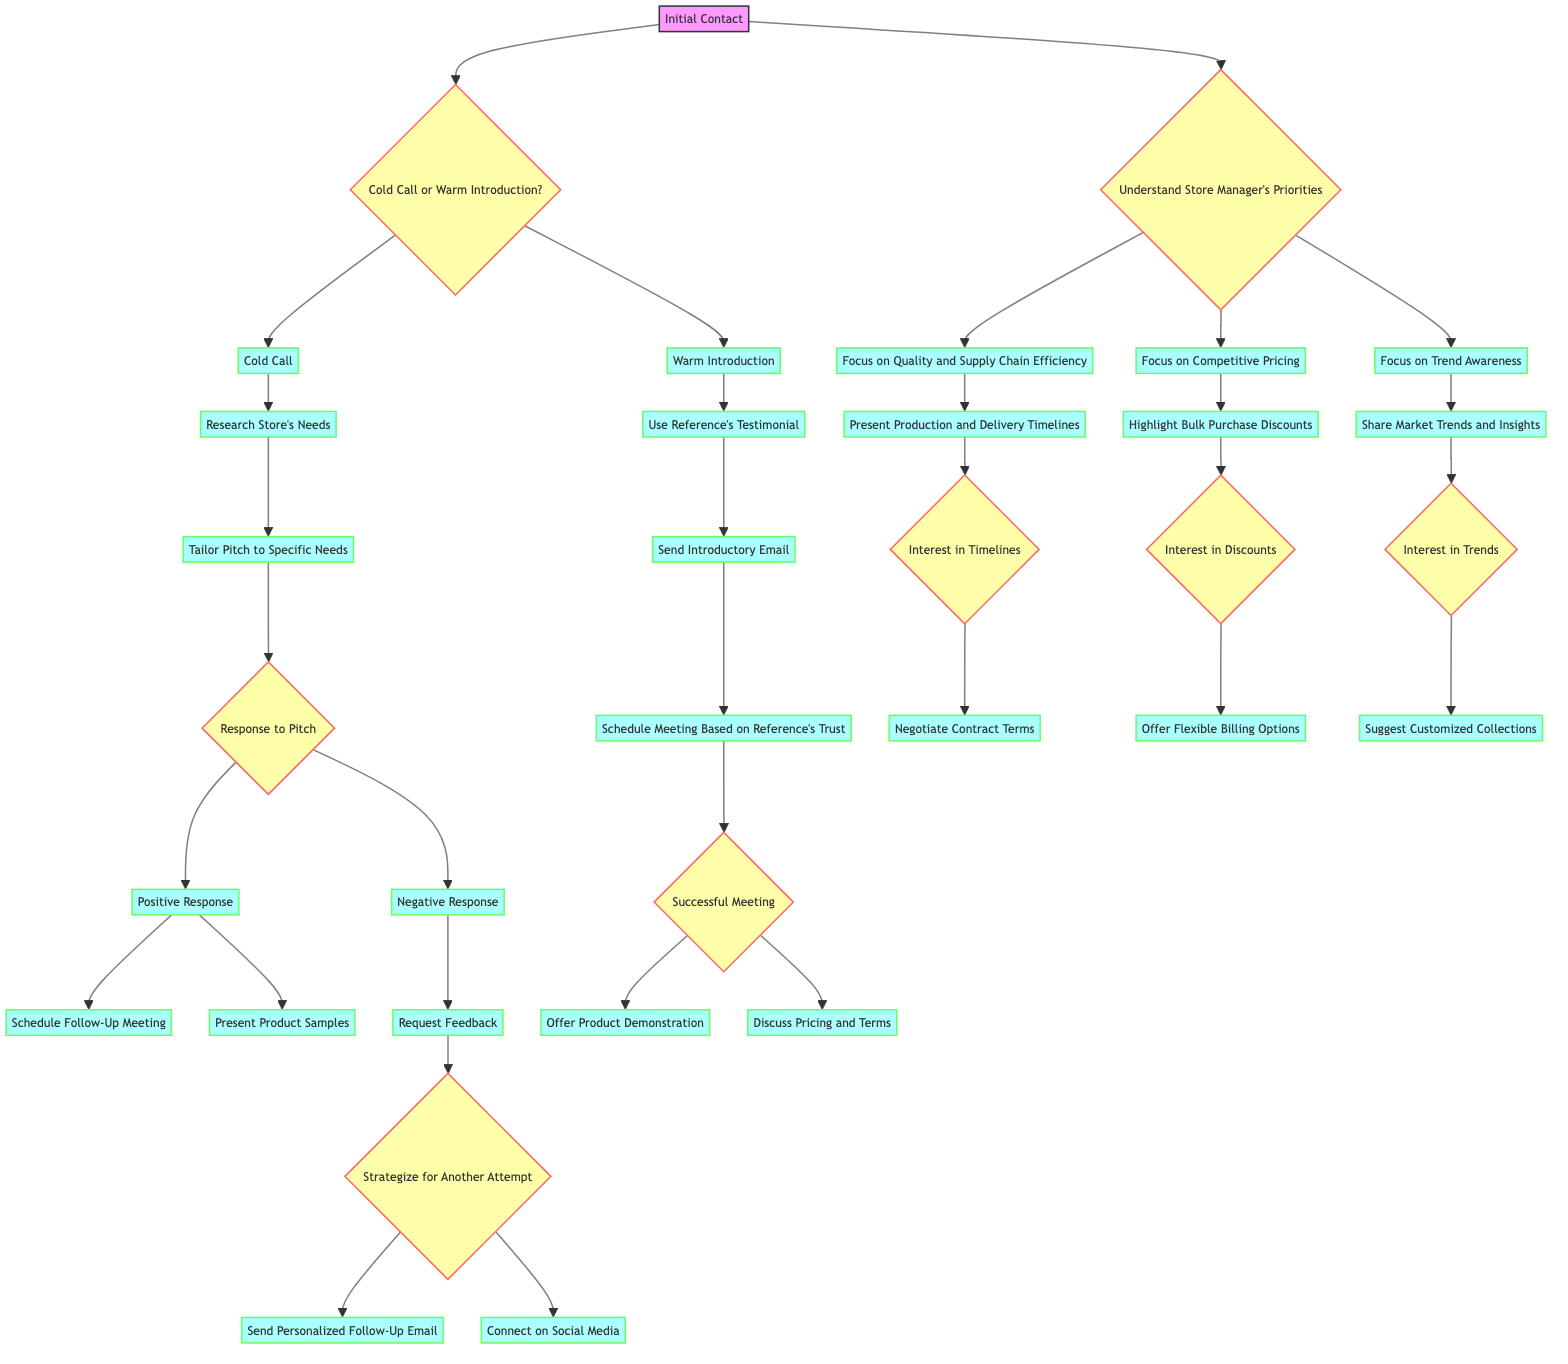What is the starting action in this decision tree? The starting action is indicated by the root node at the top of the diagram, which is "Initial Contact."
Answer: Initial Contact How many main branches are there from the "Cold Call or Warm Introduction" decision? The decision labeled "Cold Call or Warm Introduction" leads to two distinct branches: "Cold Call" and "Warm Introduction," totaling two main branches.
Answer: 2 What action follows a positive response to the tailored pitch? After a positive response is given in the response to the pitch, two actions are presented, one of which is to "Schedule Follow-Up Meeting."
Answer: Schedule Follow-Up Meeting What decision occurs after the "Research Store's Needs" action? The "Research Store's Needs" leads to the action of tailoring the pitch to specific needs, followed by a decision point called "Response to Pitch."
Answer: Response to Pitch If a store manager is interested in trends, which action is suggested next? According to the flow, following the interest in trends, the next suggested action is to "Suggest Customized Collections."
Answer: Suggest Customized Collections What happens if the meeting based on the reference's trust is unsuccessful? The diagram does not explicitly state subsequent actions for an unsuccessful meeting, suggesting that the flow ends there at the successful meeting decision.
Answer: No specific action If a store manager expresses interest in delivery timelines, what is the next action suggested? If there is an interest in timelines, the next action suggested is to "Negotiate Contract Terms," indicating the flow of decisions.
Answer: Negotiate Contract Terms Which action is taken if the response to the pitch is negative? If the response to the pitch is negative, the action taken next is to "Request Feedback," continuing the decision-making process.
Answer: Request Feedback Which focus area has an action related to highlighting bulk purchase discounts? The focus area that leads to highlighting bulk purchase discounts is "Focus on Competitive Pricing," which indicates its relevance in sales strategy.
Answer: Focus on Competitive Pricing 